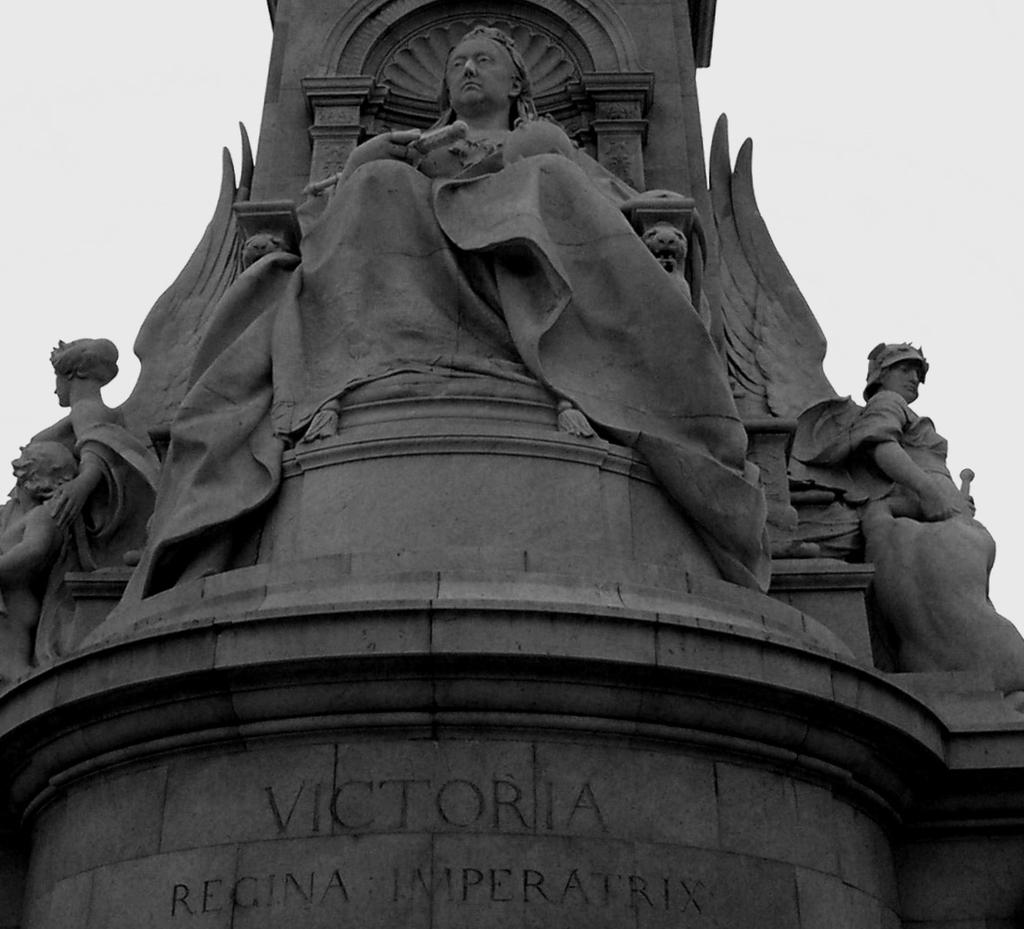What type of art can be seen in the image? There are sculptures in the image. What else can be found on the wall in the image? There are letters carved on the wall in the image. What can be seen in the background of the image? The sky is visible in the background of the image. Where is the chair located in the image? There is no chair present in the image. Can you tell me how many basketballs are visible in the image? There are no basketballs present in the image. 